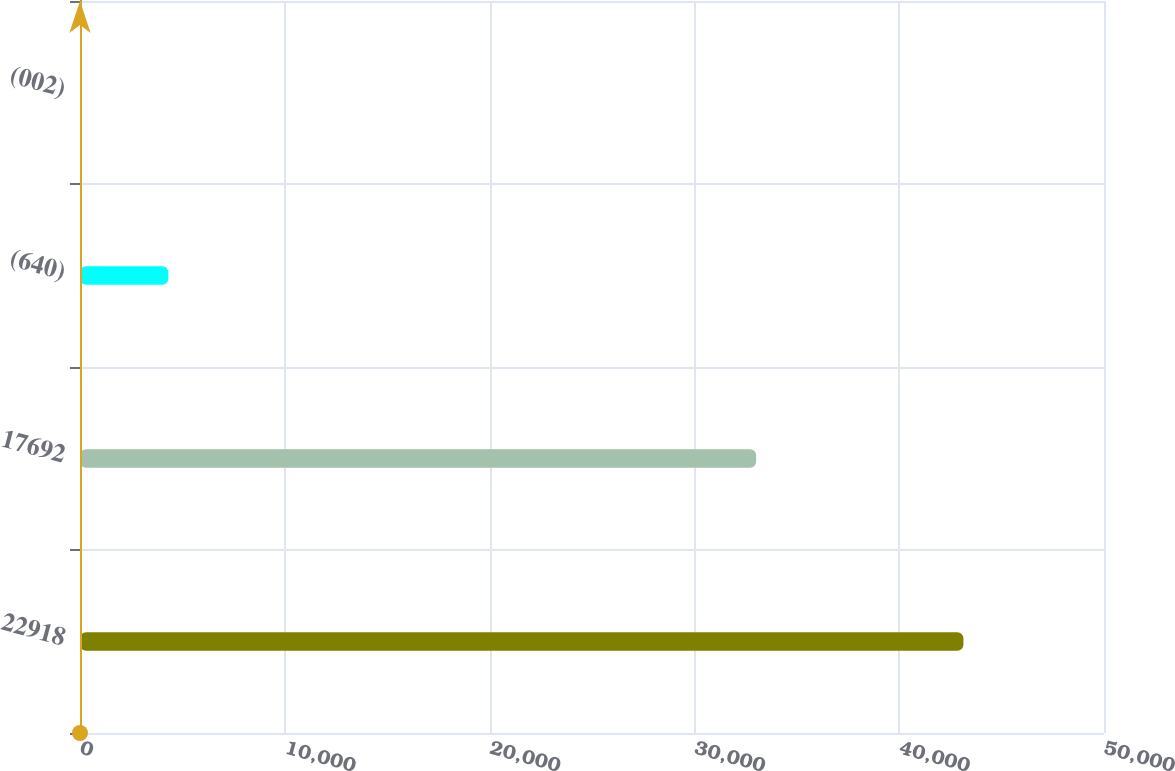<chart> <loc_0><loc_0><loc_500><loc_500><bar_chart><fcel>22918<fcel>17692<fcel>(640)<fcel>(002)<nl><fcel>43135<fcel>33014<fcel>4313.57<fcel>0.08<nl></chart> 